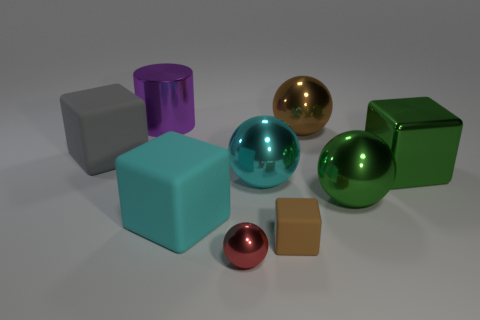Is there anything else that is the same shape as the purple metallic object?
Your response must be concise. No. The brown matte object has what shape?
Provide a succinct answer. Cube. What is the material of the large cube behind the big cube right of the brown thing behind the tiny brown rubber thing?
Make the answer very short. Rubber. Is the number of large gray cubes behind the cyan sphere greater than the number of cyan matte cylinders?
Give a very brief answer. Yes. There is a block that is the same size as the red shiny sphere; what is its material?
Provide a succinct answer. Rubber. Are there any brown shiny objects that have the same size as the cyan cube?
Your answer should be very brief. Yes. What size is the rubber block to the left of the large shiny cylinder?
Keep it short and to the point. Large. How big is the cyan block?
Give a very brief answer. Large. What number of spheres are tiny brown metallic objects or cyan matte things?
Your response must be concise. 0. There is a red sphere that is made of the same material as the green ball; what size is it?
Provide a short and direct response. Small. 